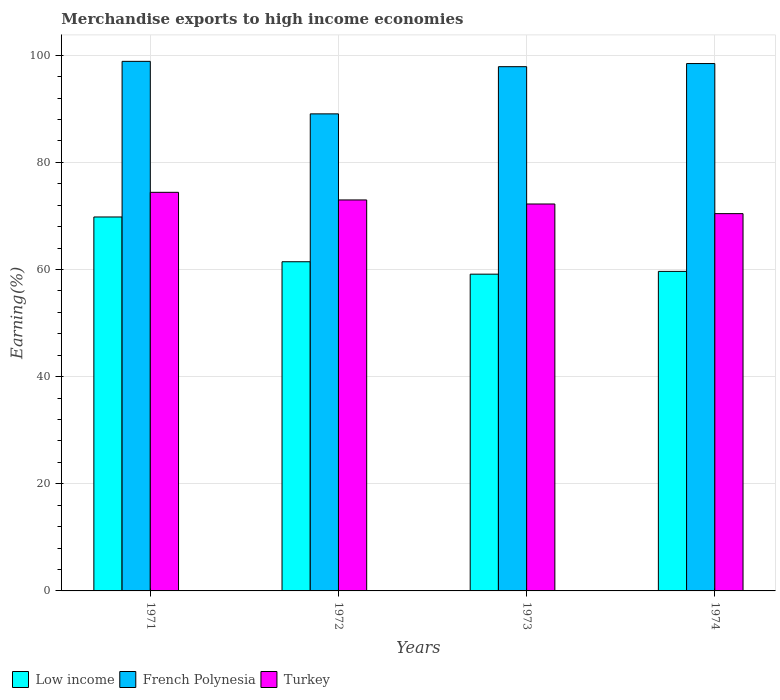How many groups of bars are there?
Give a very brief answer. 4. Are the number of bars per tick equal to the number of legend labels?
Keep it short and to the point. Yes. Are the number of bars on each tick of the X-axis equal?
Provide a succinct answer. Yes. How many bars are there on the 1st tick from the left?
Your answer should be compact. 3. How many bars are there on the 1st tick from the right?
Make the answer very short. 3. What is the percentage of amount earned from merchandise exports in Low income in 1972?
Provide a succinct answer. 61.44. Across all years, what is the maximum percentage of amount earned from merchandise exports in French Polynesia?
Give a very brief answer. 98.84. Across all years, what is the minimum percentage of amount earned from merchandise exports in French Polynesia?
Your answer should be compact. 89.04. In which year was the percentage of amount earned from merchandise exports in French Polynesia minimum?
Provide a succinct answer. 1972. What is the total percentage of amount earned from merchandise exports in Turkey in the graph?
Your response must be concise. 290.01. What is the difference between the percentage of amount earned from merchandise exports in French Polynesia in 1972 and that in 1974?
Ensure brevity in your answer.  -9.39. What is the difference between the percentage of amount earned from merchandise exports in French Polynesia in 1973 and the percentage of amount earned from merchandise exports in Turkey in 1974?
Your answer should be very brief. 27.43. What is the average percentage of amount earned from merchandise exports in Turkey per year?
Your answer should be very brief. 72.5. In the year 1974, what is the difference between the percentage of amount earned from merchandise exports in Turkey and percentage of amount earned from merchandise exports in Low income?
Provide a succinct answer. 10.78. What is the ratio of the percentage of amount earned from merchandise exports in Low income in 1971 to that in 1972?
Your answer should be very brief. 1.14. Is the percentage of amount earned from merchandise exports in Low income in 1972 less than that in 1973?
Provide a succinct answer. No. Is the difference between the percentage of amount earned from merchandise exports in Turkey in 1971 and 1974 greater than the difference between the percentage of amount earned from merchandise exports in Low income in 1971 and 1974?
Your response must be concise. No. What is the difference between the highest and the second highest percentage of amount earned from merchandise exports in Turkey?
Offer a very short reply. 1.42. What is the difference between the highest and the lowest percentage of amount earned from merchandise exports in Low income?
Make the answer very short. 10.68. What does the 2nd bar from the left in 1974 represents?
Your answer should be compact. French Polynesia. What does the 2nd bar from the right in 1974 represents?
Ensure brevity in your answer.  French Polynesia. How many bars are there?
Provide a succinct answer. 12. Are all the bars in the graph horizontal?
Ensure brevity in your answer.  No. What is the difference between two consecutive major ticks on the Y-axis?
Your answer should be compact. 20. Does the graph contain grids?
Provide a short and direct response. Yes. What is the title of the graph?
Make the answer very short. Merchandise exports to high income economies. Does "Sudan" appear as one of the legend labels in the graph?
Ensure brevity in your answer.  No. What is the label or title of the X-axis?
Your answer should be very brief. Years. What is the label or title of the Y-axis?
Ensure brevity in your answer.  Earning(%). What is the Earning(%) in Low income in 1971?
Provide a short and direct response. 69.8. What is the Earning(%) of French Polynesia in 1971?
Offer a terse response. 98.84. What is the Earning(%) of Turkey in 1971?
Provide a short and direct response. 74.4. What is the Earning(%) in Low income in 1972?
Ensure brevity in your answer.  61.44. What is the Earning(%) of French Polynesia in 1972?
Keep it short and to the point. 89.04. What is the Earning(%) of Turkey in 1972?
Offer a terse response. 72.98. What is the Earning(%) in Low income in 1973?
Your answer should be very brief. 59.12. What is the Earning(%) in French Polynesia in 1973?
Provide a short and direct response. 97.85. What is the Earning(%) of Turkey in 1973?
Give a very brief answer. 72.22. What is the Earning(%) in Low income in 1974?
Your answer should be very brief. 59.64. What is the Earning(%) of French Polynesia in 1974?
Offer a very short reply. 98.43. What is the Earning(%) in Turkey in 1974?
Ensure brevity in your answer.  70.42. Across all years, what is the maximum Earning(%) of Low income?
Give a very brief answer. 69.8. Across all years, what is the maximum Earning(%) of French Polynesia?
Make the answer very short. 98.84. Across all years, what is the maximum Earning(%) of Turkey?
Provide a short and direct response. 74.4. Across all years, what is the minimum Earning(%) of Low income?
Offer a terse response. 59.12. Across all years, what is the minimum Earning(%) of French Polynesia?
Your response must be concise. 89.04. Across all years, what is the minimum Earning(%) of Turkey?
Your answer should be compact. 70.42. What is the total Earning(%) of Low income in the graph?
Your answer should be very brief. 250. What is the total Earning(%) of French Polynesia in the graph?
Ensure brevity in your answer.  384.17. What is the total Earning(%) in Turkey in the graph?
Keep it short and to the point. 290.01. What is the difference between the Earning(%) in Low income in 1971 and that in 1972?
Provide a succinct answer. 8.35. What is the difference between the Earning(%) of French Polynesia in 1971 and that in 1972?
Give a very brief answer. 9.8. What is the difference between the Earning(%) in Turkey in 1971 and that in 1972?
Keep it short and to the point. 1.42. What is the difference between the Earning(%) in Low income in 1971 and that in 1973?
Provide a short and direct response. 10.68. What is the difference between the Earning(%) in Turkey in 1971 and that in 1973?
Offer a terse response. 2.18. What is the difference between the Earning(%) in Low income in 1971 and that in 1974?
Your response must be concise. 10.16. What is the difference between the Earning(%) in French Polynesia in 1971 and that in 1974?
Give a very brief answer. 0.41. What is the difference between the Earning(%) in Turkey in 1971 and that in 1974?
Ensure brevity in your answer.  3.98. What is the difference between the Earning(%) of Low income in 1972 and that in 1973?
Your answer should be very brief. 2.32. What is the difference between the Earning(%) in French Polynesia in 1972 and that in 1973?
Provide a succinct answer. -8.81. What is the difference between the Earning(%) of Turkey in 1972 and that in 1973?
Give a very brief answer. 0.76. What is the difference between the Earning(%) in Low income in 1972 and that in 1974?
Offer a very short reply. 1.8. What is the difference between the Earning(%) in French Polynesia in 1972 and that in 1974?
Give a very brief answer. -9.39. What is the difference between the Earning(%) in Turkey in 1972 and that in 1974?
Offer a terse response. 2.56. What is the difference between the Earning(%) of Low income in 1973 and that in 1974?
Offer a very short reply. -0.52. What is the difference between the Earning(%) of French Polynesia in 1973 and that in 1974?
Give a very brief answer. -0.58. What is the difference between the Earning(%) in Turkey in 1973 and that in 1974?
Provide a short and direct response. 1.8. What is the difference between the Earning(%) of Low income in 1971 and the Earning(%) of French Polynesia in 1972?
Give a very brief answer. -19.24. What is the difference between the Earning(%) in Low income in 1971 and the Earning(%) in Turkey in 1972?
Make the answer very short. -3.18. What is the difference between the Earning(%) in French Polynesia in 1971 and the Earning(%) in Turkey in 1972?
Give a very brief answer. 25.87. What is the difference between the Earning(%) of Low income in 1971 and the Earning(%) of French Polynesia in 1973?
Give a very brief answer. -28.05. What is the difference between the Earning(%) of Low income in 1971 and the Earning(%) of Turkey in 1973?
Offer a terse response. -2.42. What is the difference between the Earning(%) of French Polynesia in 1971 and the Earning(%) of Turkey in 1973?
Provide a succinct answer. 26.62. What is the difference between the Earning(%) of Low income in 1971 and the Earning(%) of French Polynesia in 1974?
Your response must be concise. -28.64. What is the difference between the Earning(%) in Low income in 1971 and the Earning(%) in Turkey in 1974?
Your response must be concise. -0.62. What is the difference between the Earning(%) in French Polynesia in 1971 and the Earning(%) in Turkey in 1974?
Provide a succinct answer. 28.42. What is the difference between the Earning(%) in Low income in 1972 and the Earning(%) in French Polynesia in 1973?
Make the answer very short. -36.41. What is the difference between the Earning(%) in Low income in 1972 and the Earning(%) in Turkey in 1973?
Offer a terse response. -10.78. What is the difference between the Earning(%) in French Polynesia in 1972 and the Earning(%) in Turkey in 1973?
Your answer should be very brief. 16.82. What is the difference between the Earning(%) of Low income in 1972 and the Earning(%) of French Polynesia in 1974?
Your answer should be very brief. -36.99. What is the difference between the Earning(%) in Low income in 1972 and the Earning(%) in Turkey in 1974?
Keep it short and to the point. -8.98. What is the difference between the Earning(%) of French Polynesia in 1972 and the Earning(%) of Turkey in 1974?
Your response must be concise. 18.62. What is the difference between the Earning(%) of Low income in 1973 and the Earning(%) of French Polynesia in 1974?
Provide a succinct answer. -39.31. What is the difference between the Earning(%) in Low income in 1973 and the Earning(%) in Turkey in 1974?
Ensure brevity in your answer.  -11.3. What is the difference between the Earning(%) in French Polynesia in 1973 and the Earning(%) in Turkey in 1974?
Your answer should be very brief. 27.43. What is the average Earning(%) of Low income per year?
Offer a very short reply. 62.5. What is the average Earning(%) in French Polynesia per year?
Give a very brief answer. 96.04. What is the average Earning(%) of Turkey per year?
Make the answer very short. 72.5. In the year 1971, what is the difference between the Earning(%) of Low income and Earning(%) of French Polynesia?
Your response must be concise. -29.05. In the year 1971, what is the difference between the Earning(%) in Low income and Earning(%) in Turkey?
Offer a very short reply. -4.6. In the year 1971, what is the difference between the Earning(%) of French Polynesia and Earning(%) of Turkey?
Your answer should be very brief. 24.45. In the year 1972, what is the difference between the Earning(%) in Low income and Earning(%) in French Polynesia?
Offer a terse response. -27.6. In the year 1972, what is the difference between the Earning(%) of Low income and Earning(%) of Turkey?
Provide a succinct answer. -11.53. In the year 1972, what is the difference between the Earning(%) of French Polynesia and Earning(%) of Turkey?
Your answer should be very brief. 16.07. In the year 1973, what is the difference between the Earning(%) of Low income and Earning(%) of French Polynesia?
Your answer should be compact. -38.73. In the year 1973, what is the difference between the Earning(%) of Low income and Earning(%) of Turkey?
Make the answer very short. -13.1. In the year 1973, what is the difference between the Earning(%) of French Polynesia and Earning(%) of Turkey?
Your answer should be very brief. 25.63. In the year 1974, what is the difference between the Earning(%) in Low income and Earning(%) in French Polynesia?
Your answer should be compact. -38.79. In the year 1974, what is the difference between the Earning(%) of Low income and Earning(%) of Turkey?
Your answer should be compact. -10.78. In the year 1974, what is the difference between the Earning(%) of French Polynesia and Earning(%) of Turkey?
Your response must be concise. 28.01. What is the ratio of the Earning(%) of Low income in 1971 to that in 1972?
Your response must be concise. 1.14. What is the ratio of the Earning(%) of French Polynesia in 1971 to that in 1972?
Your response must be concise. 1.11. What is the ratio of the Earning(%) of Turkey in 1971 to that in 1972?
Make the answer very short. 1.02. What is the ratio of the Earning(%) in Low income in 1971 to that in 1973?
Give a very brief answer. 1.18. What is the ratio of the Earning(%) of French Polynesia in 1971 to that in 1973?
Your response must be concise. 1.01. What is the ratio of the Earning(%) in Turkey in 1971 to that in 1973?
Provide a succinct answer. 1.03. What is the ratio of the Earning(%) of Low income in 1971 to that in 1974?
Your response must be concise. 1.17. What is the ratio of the Earning(%) of French Polynesia in 1971 to that in 1974?
Offer a terse response. 1. What is the ratio of the Earning(%) of Turkey in 1971 to that in 1974?
Your response must be concise. 1.06. What is the ratio of the Earning(%) of Low income in 1972 to that in 1973?
Your answer should be very brief. 1.04. What is the ratio of the Earning(%) in French Polynesia in 1972 to that in 1973?
Offer a terse response. 0.91. What is the ratio of the Earning(%) of Turkey in 1972 to that in 1973?
Provide a short and direct response. 1.01. What is the ratio of the Earning(%) in Low income in 1972 to that in 1974?
Give a very brief answer. 1.03. What is the ratio of the Earning(%) in French Polynesia in 1972 to that in 1974?
Your response must be concise. 0.9. What is the ratio of the Earning(%) in Turkey in 1972 to that in 1974?
Your answer should be very brief. 1.04. What is the ratio of the Earning(%) in French Polynesia in 1973 to that in 1974?
Your answer should be very brief. 0.99. What is the ratio of the Earning(%) of Turkey in 1973 to that in 1974?
Provide a succinct answer. 1.03. What is the difference between the highest and the second highest Earning(%) of Low income?
Make the answer very short. 8.35. What is the difference between the highest and the second highest Earning(%) of French Polynesia?
Offer a very short reply. 0.41. What is the difference between the highest and the second highest Earning(%) of Turkey?
Give a very brief answer. 1.42. What is the difference between the highest and the lowest Earning(%) of Low income?
Give a very brief answer. 10.68. What is the difference between the highest and the lowest Earning(%) in French Polynesia?
Your answer should be very brief. 9.8. What is the difference between the highest and the lowest Earning(%) in Turkey?
Your response must be concise. 3.98. 